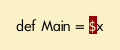Convert code to text. <code><loc_0><loc_0><loc_500><loc_500><_SQL_>def Main = $x
</code> 